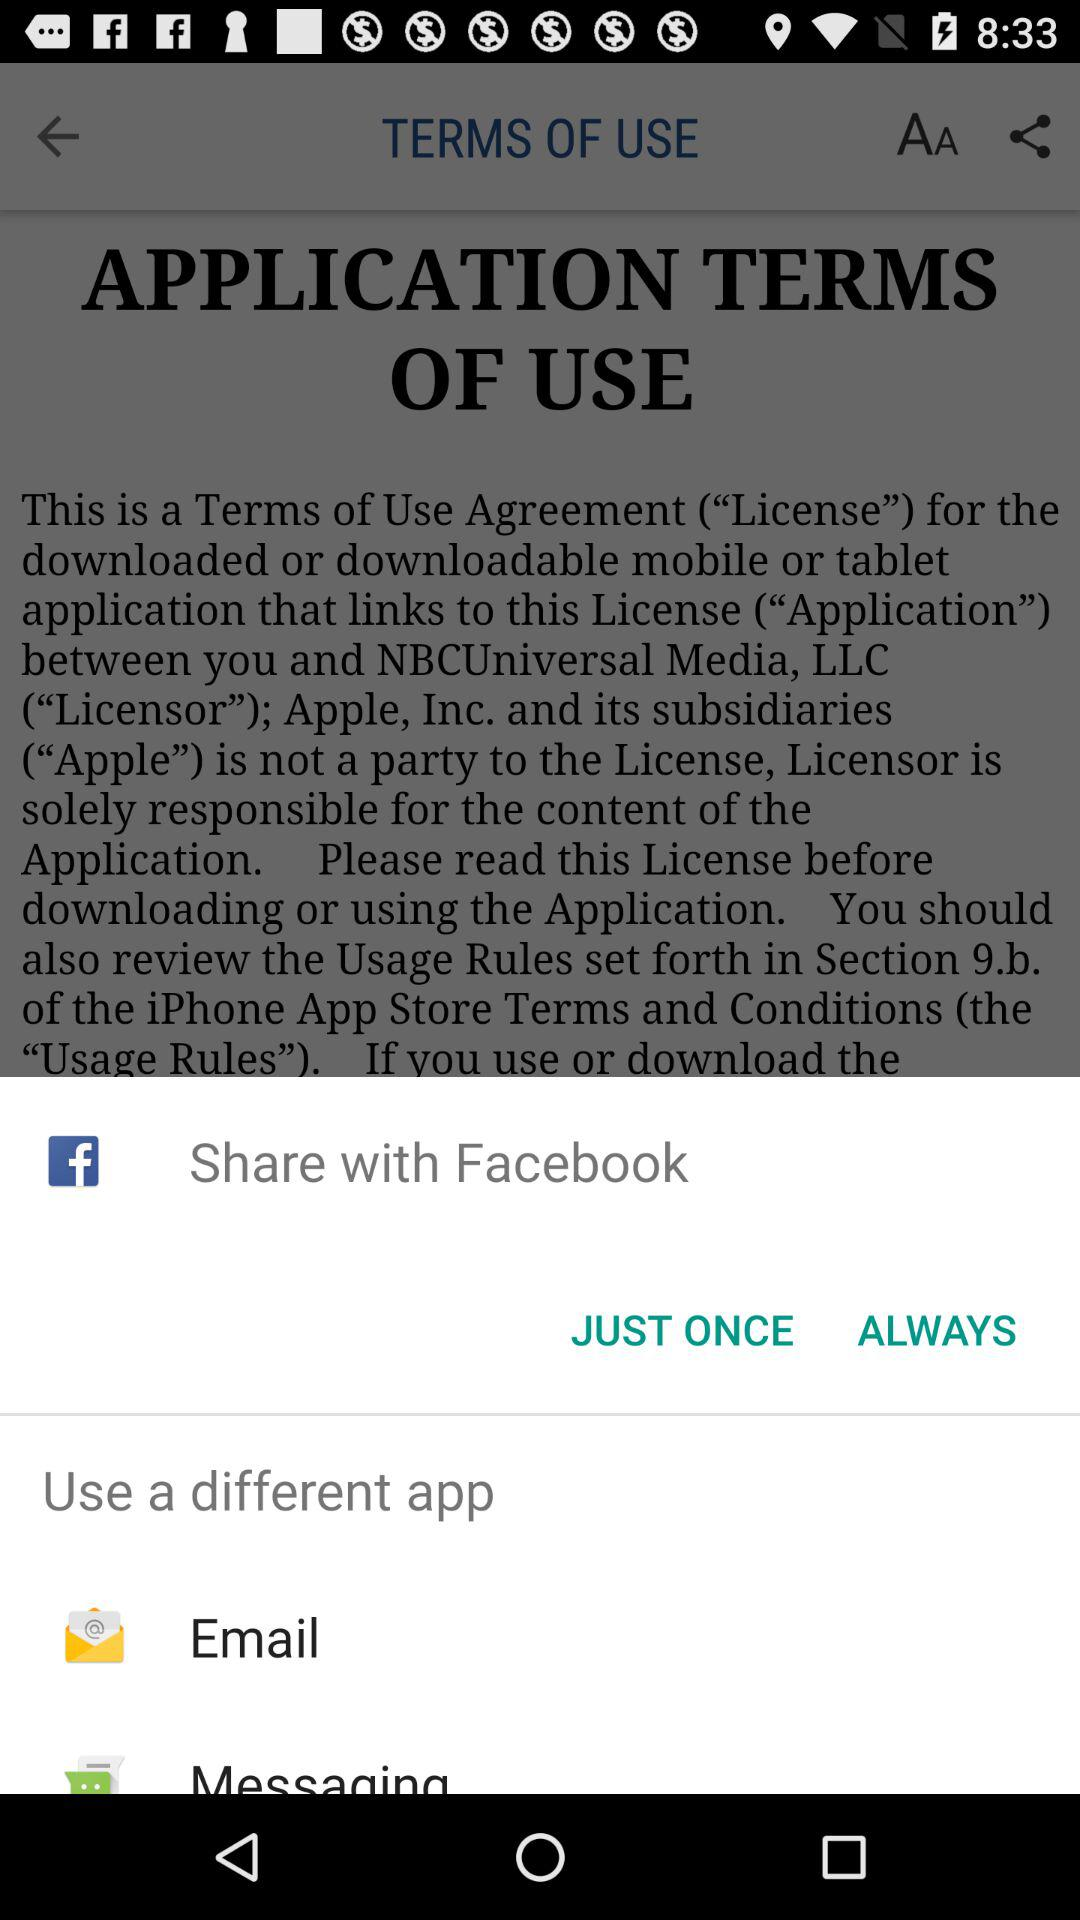What is the headline of article? The headline is "TERMS OF USE". 